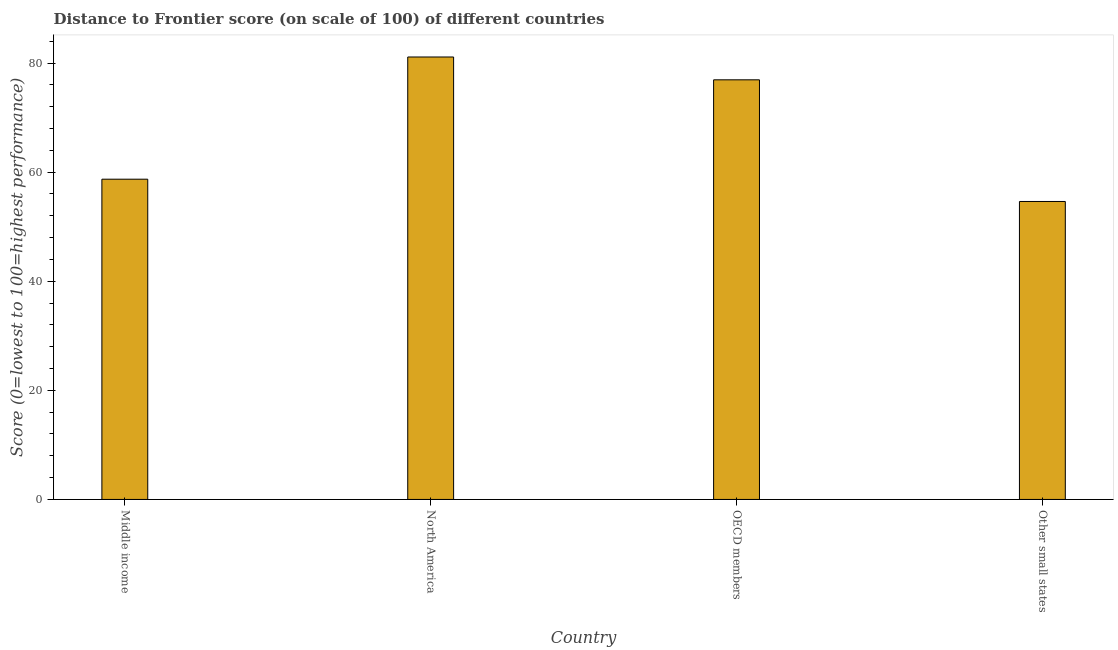Does the graph contain any zero values?
Ensure brevity in your answer.  No. What is the title of the graph?
Your response must be concise. Distance to Frontier score (on scale of 100) of different countries. What is the label or title of the Y-axis?
Provide a short and direct response. Score (0=lowest to 100=highest performance). What is the distance to frontier score in OECD members?
Your answer should be compact. 76.93. Across all countries, what is the maximum distance to frontier score?
Keep it short and to the point. 81.11. Across all countries, what is the minimum distance to frontier score?
Keep it short and to the point. 54.62. In which country was the distance to frontier score minimum?
Offer a very short reply. Other small states. What is the sum of the distance to frontier score?
Provide a short and direct response. 271.37. What is the difference between the distance to frontier score in Middle income and Other small states?
Provide a succinct answer. 4.08. What is the average distance to frontier score per country?
Your answer should be very brief. 67.84. What is the median distance to frontier score?
Keep it short and to the point. 67.82. What is the ratio of the distance to frontier score in Middle income to that in North America?
Make the answer very short. 0.72. Is the distance to frontier score in Middle income less than that in OECD members?
Ensure brevity in your answer.  Yes. Is the difference between the distance to frontier score in North America and Other small states greater than the difference between any two countries?
Your answer should be very brief. Yes. What is the difference between the highest and the second highest distance to frontier score?
Provide a short and direct response. 4.18. Is the sum of the distance to frontier score in North America and OECD members greater than the maximum distance to frontier score across all countries?
Ensure brevity in your answer.  Yes. What is the difference between the highest and the lowest distance to frontier score?
Your answer should be compact. 26.49. In how many countries, is the distance to frontier score greater than the average distance to frontier score taken over all countries?
Your response must be concise. 2. How many bars are there?
Your answer should be very brief. 4. Are the values on the major ticks of Y-axis written in scientific E-notation?
Make the answer very short. No. What is the Score (0=lowest to 100=highest performance) in Middle income?
Ensure brevity in your answer.  58.71. What is the Score (0=lowest to 100=highest performance) in North America?
Give a very brief answer. 81.11. What is the Score (0=lowest to 100=highest performance) of OECD members?
Your answer should be very brief. 76.93. What is the Score (0=lowest to 100=highest performance) in Other small states?
Provide a succinct answer. 54.62. What is the difference between the Score (0=lowest to 100=highest performance) in Middle income and North America?
Your answer should be very brief. -22.4. What is the difference between the Score (0=lowest to 100=highest performance) in Middle income and OECD members?
Your answer should be very brief. -18.22. What is the difference between the Score (0=lowest to 100=highest performance) in Middle income and Other small states?
Provide a succinct answer. 4.09. What is the difference between the Score (0=lowest to 100=highest performance) in North America and OECD members?
Your answer should be very brief. 4.18. What is the difference between the Score (0=lowest to 100=highest performance) in North America and Other small states?
Your answer should be very brief. 26.49. What is the difference between the Score (0=lowest to 100=highest performance) in OECD members and Other small states?
Make the answer very short. 22.3. What is the ratio of the Score (0=lowest to 100=highest performance) in Middle income to that in North America?
Offer a very short reply. 0.72. What is the ratio of the Score (0=lowest to 100=highest performance) in Middle income to that in OECD members?
Ensure brevity in your answer.  0.76. What is the ratio of the Score (0=lowest to 100=highest performance) in Middle income to that in Other small states?
Offer a very short reply. 1.07. What is the ratio of the Score (0=lowest to 100=highest performance) in North America to that in OECD members?
Your response must be concise. 1.05. What is the ratio of the Score (0=lowest to 100=highest performance) in North America to that in Other small states?
Your answer should be very brief. 1.49. What is the ratio of the Score (0=lowest to 100=highest performance) in OECD members to that in Other small states?
Keep it short and to the point. 1.41. 